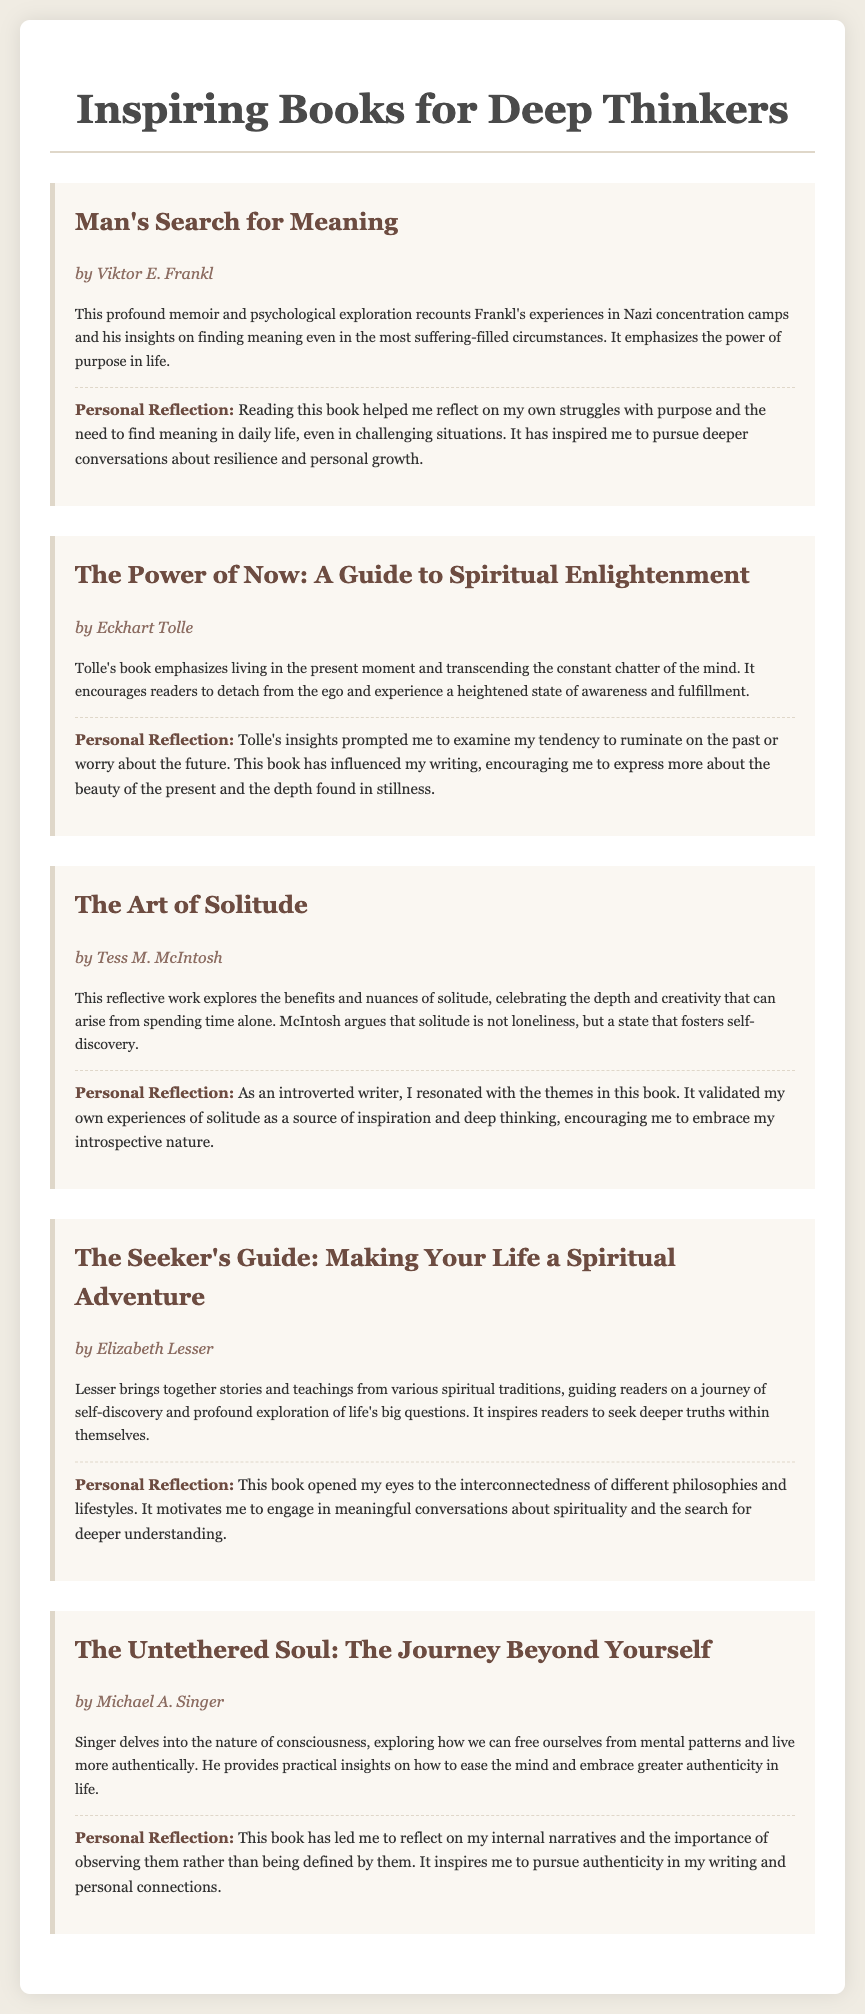What is the title of the first book listed? The title of the first book listed is the first book referenced in the document.
Answer: Man's Search for Meaning Who is the author of "The Power of Now"? The author's name is mentioned immediately following the book title.
Answer: Eckhart Tolle How many books are included in this note? The number of books can be determined by counting the individual entries in the document.
Answer: Five What theme does "The Art of Solitude" explore? The theme is specified in the annotation, indicating the focus of the book.
Answer: Solitude Which book discusses the nature of consciousness? The book that covers this topic is indicated in the description within the document.
Answer: The Untethered Soul What is a personal reflection mentioned for "The Seeker's Guide"? The personal reflection provides insight into how the book influenced the writer.
Answer: Interconnectedness of different philosophies What style of writing does the document employ? The document is structured and presented in a clear and organized format.
Answer: Annotated list Which author wrote a memoir about experiences in Nazi concentration camps? This information is found within the specific annotation for the corresponding book.
Answer: Viktor E. Frankl What is a major takeaway from "The Untethered Soul"? The major takeaway is summarized in the reflection regarding personal growth and self-awareness.
Answer: Authenticity 